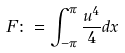Convert formula to latex. <formula><loc_0><loc_0><loc_500><loc_500>F \colon = \int _ { - \pi } ^ { \pi } \frac { u ^ { 4 } } { 4 } d x</formula> 